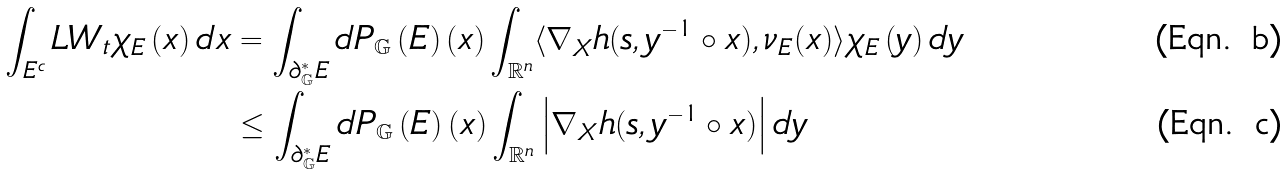Convert formula to latex. <formula><loc_0><loc_0><loc_500><loc_500>\int _ { E ^ { c } } L W _ { t } \chi _ { E } \left ( x \right ) d x & = \int _ { \partial _ { \mathbb { G } } ^ { \ast } E } d P _ { \mathbb { G } } \left ( E \right ) \left ( x \right ) \int _ { \mathbb { R } ^ { n } } \langle \nabla _ { X } h ( s , y ^ { - 1 } \circ x ) , \nu _ { E } ( x ) \rangle \chi _ { E } \left ( y \right ) d y \\ & \leq \int _ { \partial _ { \mathbb { G } } ^ { \ast } E } d P _ { \mathbb { G } } \left ( E \right ) \left ( x \right ) \int _ { \mathbb { R } ^ { n } } \left | \nabla _ { X } h ( s , y ^ { - 1 } \circ x ) \right | d y</formula> 